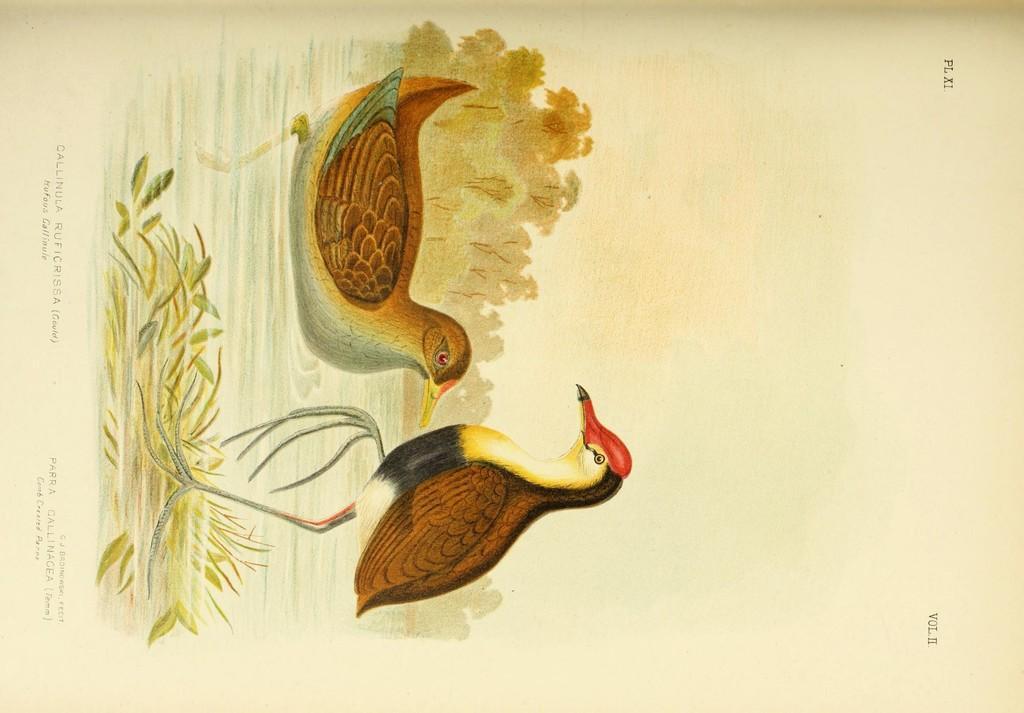In one or two sentences, can you explain what this image depicts? It is a painted image. In this image there are two birds. There is grass. There are trees and there is some text written at the bottom of the image. 